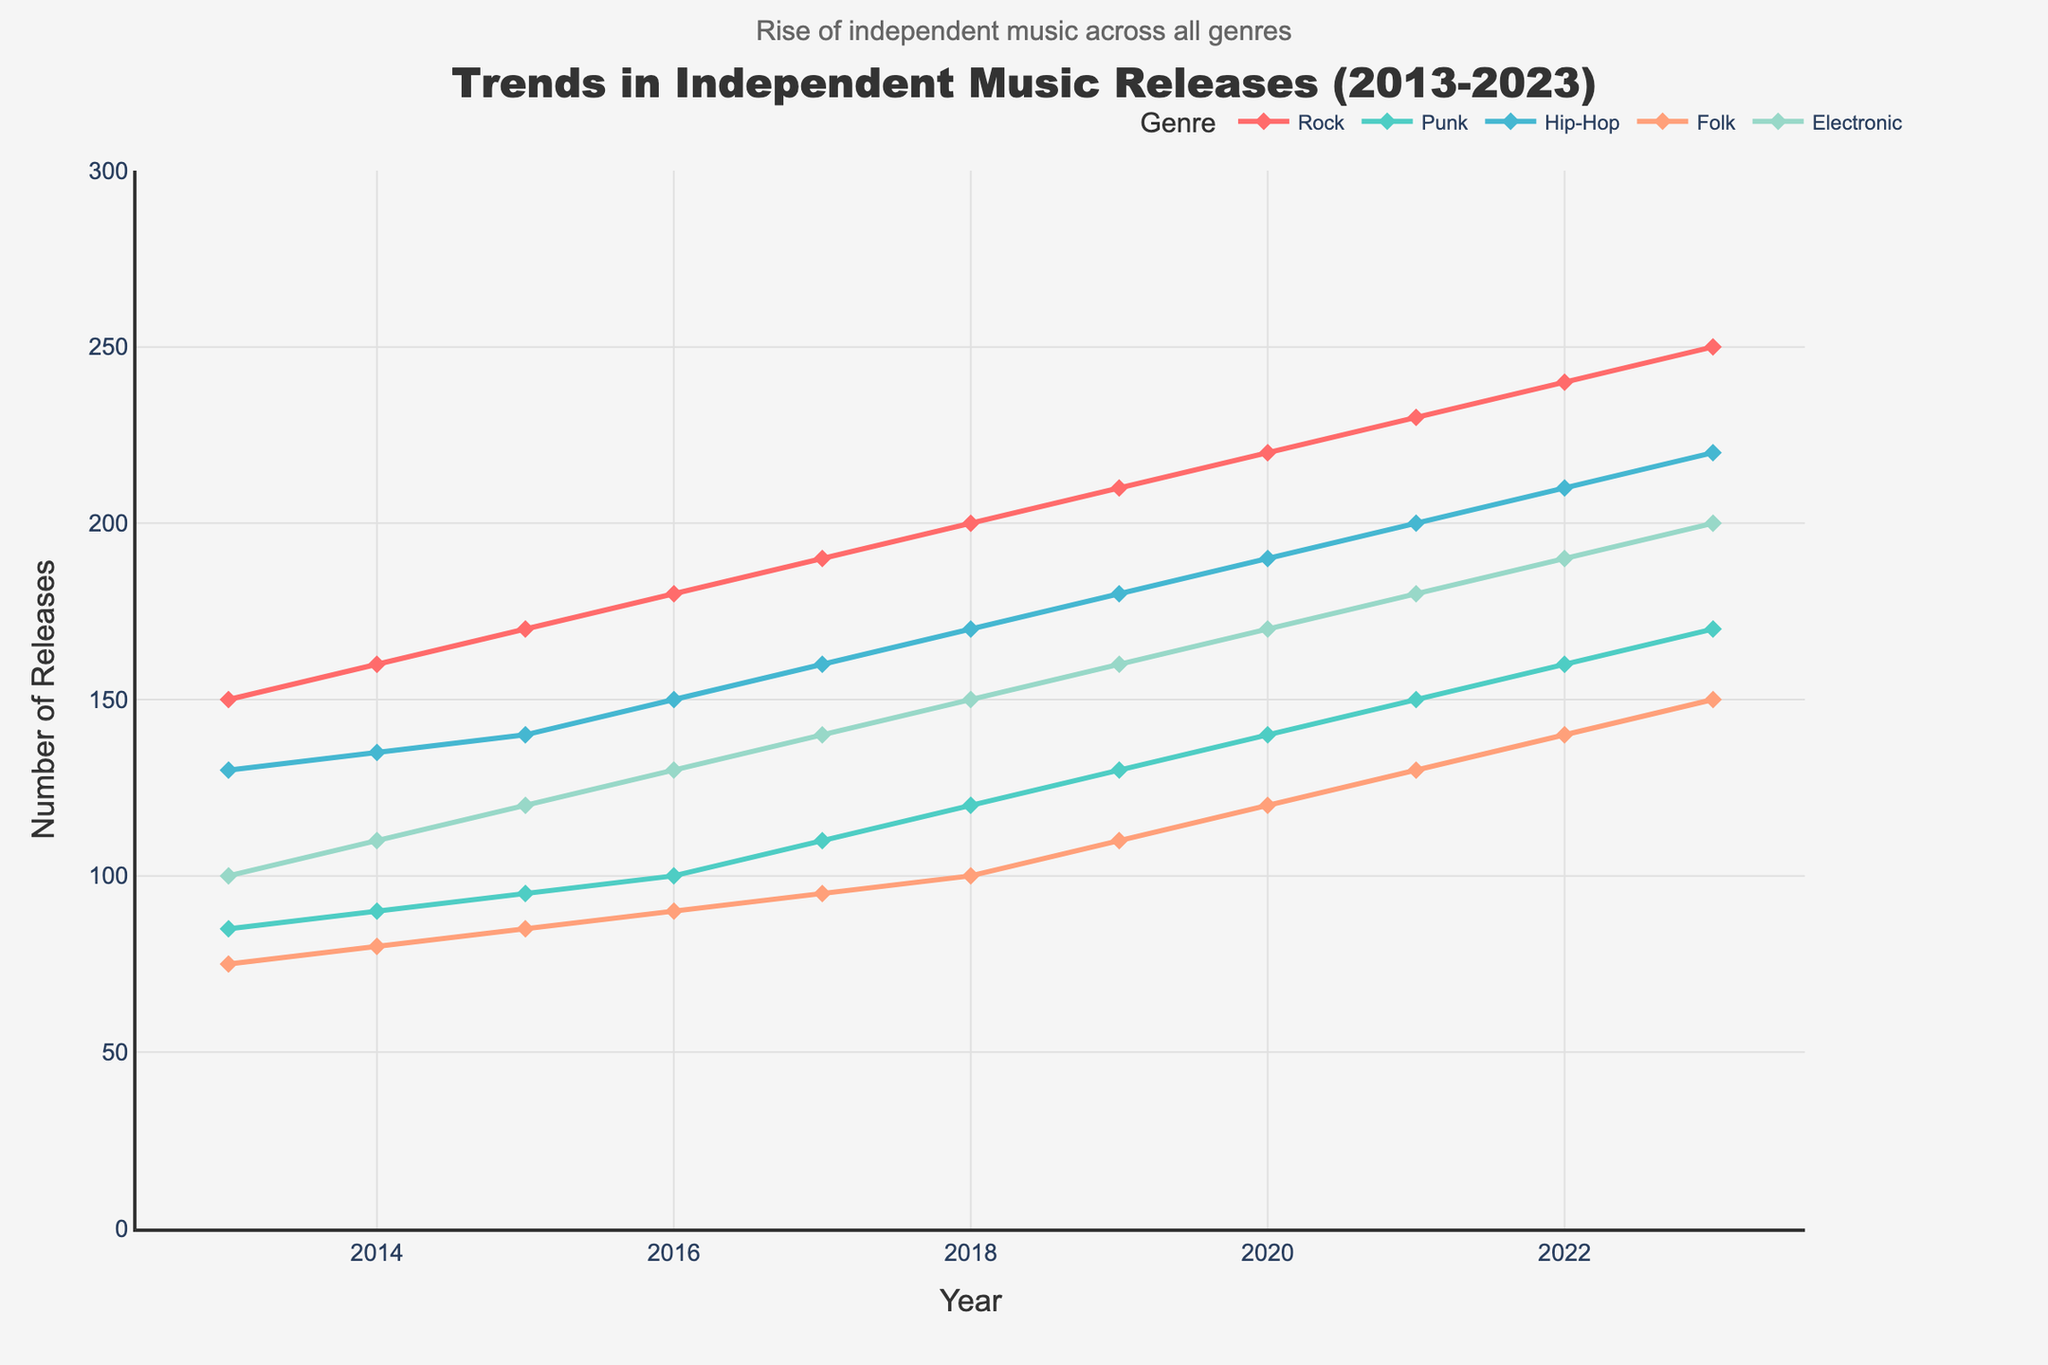what is the trend in the number of independent rock releases from 2013 to 2023? The trend shows a steady increase in independent rock releases each year from 150 in 2013 to 250 in 2023.
Answer: steady increase How many genres are tracked in the figure? The figure tracks five different genres, as shown by the number of lines and legend entries.
Answer: five In which year did independent electronic releases reach 150? The figure shows that independent electronic releases reached 150 in 2018.
Answer: 2018 Which genre had the highest number of releases in the final year presented? In 2023, the genre with the highest number of releases is Rock, with 250 releases.
Answer: Rock By how much did the number of independent hip-hop releases increase from 2013 to 2023? In 2013, there were 130 hip-hop releases, and in 2023, there were 220. The increase is 220 - 130 = 90.
Answer: 90 Compare the growth between punk and folk genres from 2013 to 2023. Which had a higher growth rate, and by how much? Punk grew from 85 to 170 (an increase of 85), while folk grew from 75 to 150 (an increase of 75). Punk had a higher growth rate by 85 - 75 = 10 releases.
Answer: Punk by 10 What is the average number of independent folk releases per year over the presented period? Sum the independent folk releases from 2013 to 2023: 75 + 80 + 85 + 90 + 95 + 100 + 110 + 120 + 130 + 140 + 150 = 1175, then divide by the number of years (11). The average is 1175 / 11 = 106.82.
Answer: 106.82 Which genre shows the most gradual trend change over the presented period and what indicates this? The electronic genre shows the most gradual trend change, with a consistent and smooth increase in the number of releases each year.
Answer: Electronic In 2017, which genre had the lowest number of independent releases? The figure shows that in 2017, the genre with the lowest number of independent releases was Folk, with 95 releases.
Answer: Folk 